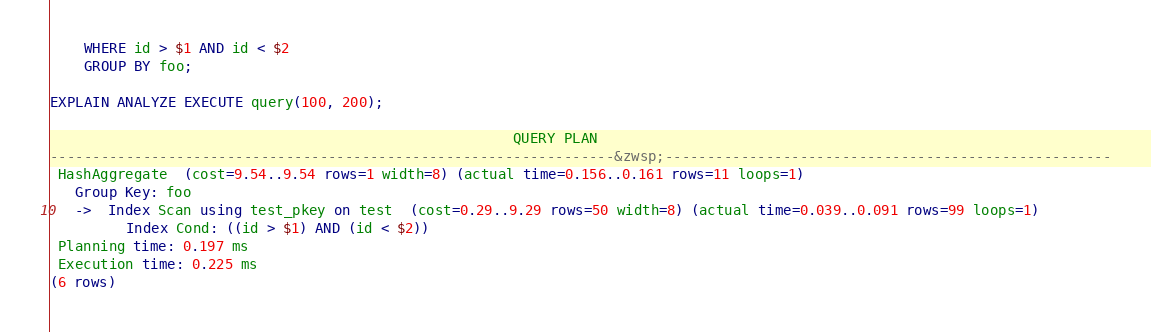<code> <loc_0><loc_0><loc_500><loc_500><_SQL_>    WHERE id > $1 AND id < $2
    GROUP BY foo;

EXPLAIN ANALYZE EXECUTE query(100, 200);

                                                       QUERY PLAN                                                       
-------------------------------------------------------------------&zwsp;-----------------------------------------------------
 HashAggregate  (cost=9.54..9.54 rows=1 width=8) (actual time=0.156..0.161 rows=11 loops=1)
   Group Key: foo
   ->  Index Scan using test_pkey on test  (cost=0.29..9.29 rows=50 width=8) (actual time=0.039..0.091 rows=99 loops=1)
         Index Cond: ((id > $1) AND (id < $2))
 Planning time: 0.197 ms
 Execution time: 0.225 ms
(6 rows)
</code> 